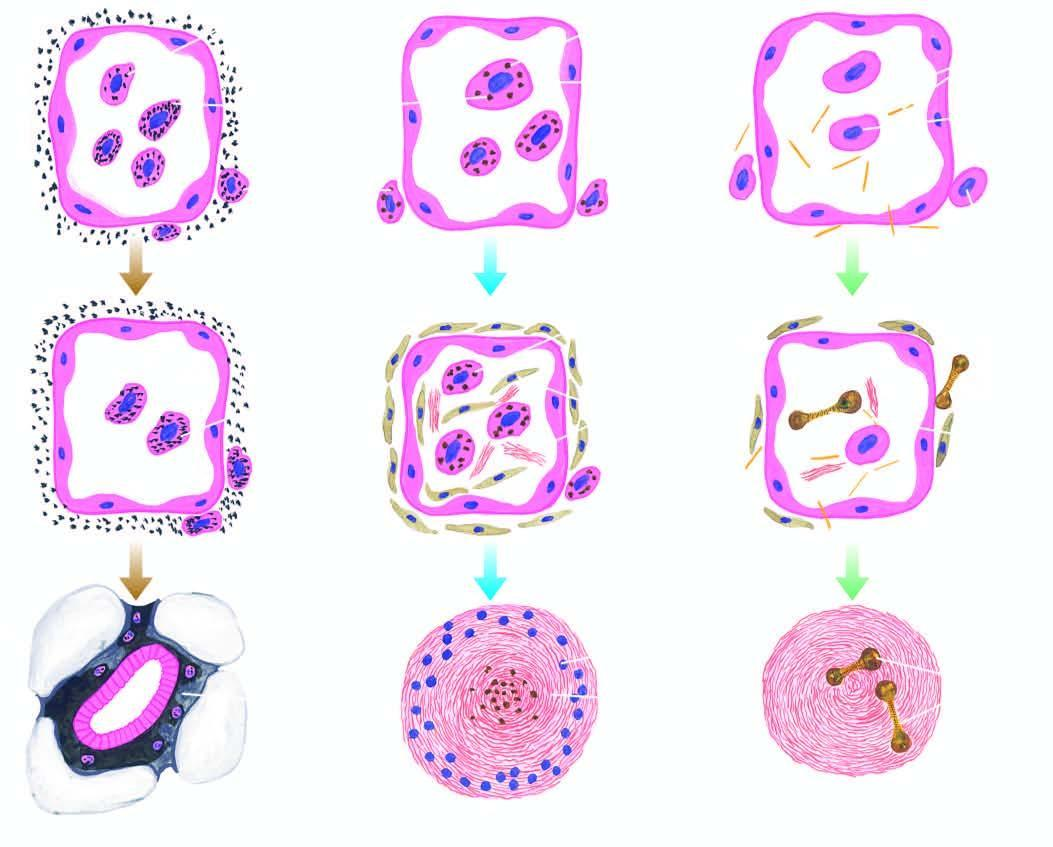what are the tiny silica particles?
Answer the question using a single word or phrase. Toxic to macrophages 